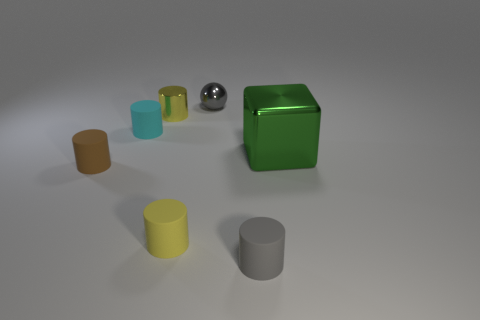Subtract all purple cylinders. Subtract all cyan cubes. How many cylinders are left? 5 Add 3 small metal balls. How many objects exist? 10 Subtract all balls. How many objects are left? 6 Add 3 gray balls. How many gray balls are left? 4 Add 6 tiny brown spheres. How many tiny brown spheres exist? 6 Subtract 0 purple cubes. How many objects are left? 7 Subtract all metal balls. Subtract all gray matte cylinders. How many objects are left? 5 